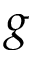<formula> <loc_0><loc_0><loc_500><loc_500>g</formula> 